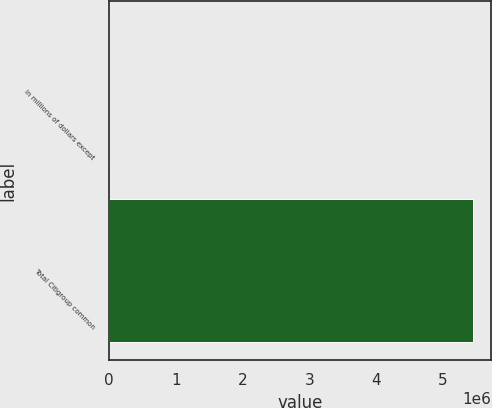<chart> <loc_0><loc_0><loc_500><loc_500><bar_chart><fcel>In millions of dollars except<fcel>Total Citigroup common<nl><fcel>2008<fcel>5.45007e+06<nl></chart> 